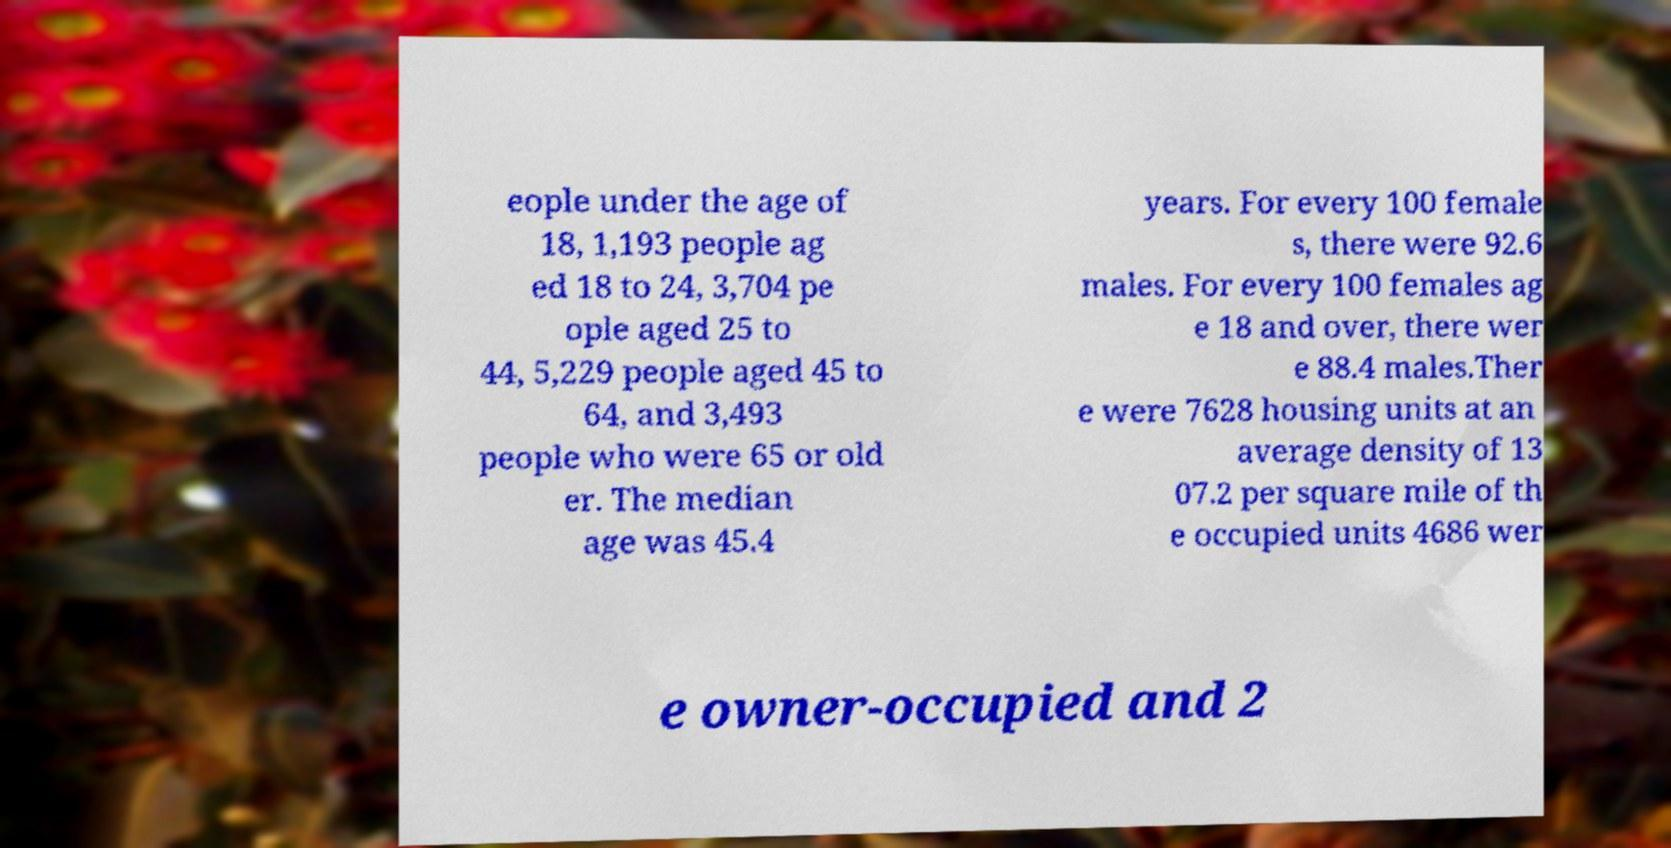Can you read and provide the text displayed in the image?This photo seems to have some interesting text. Can you extract and type it out for me? eople under the age of 18, 1,193 people ag ed 18 to 24, 3,704 pe ople aged 25 to 44, 5,229 people aged 45 to 64, and 3,493 people who were 65 or old er. The median age was 45.4 years. For every 100 female s, there were 92.6 males. For every 100 females ag e 18 and over, there wer e 88.4 males.Ther e were 7628 housing units at an average density of 13 07.2 per square mile of th e occupied units 4686 wer e owner-occupied and 2 